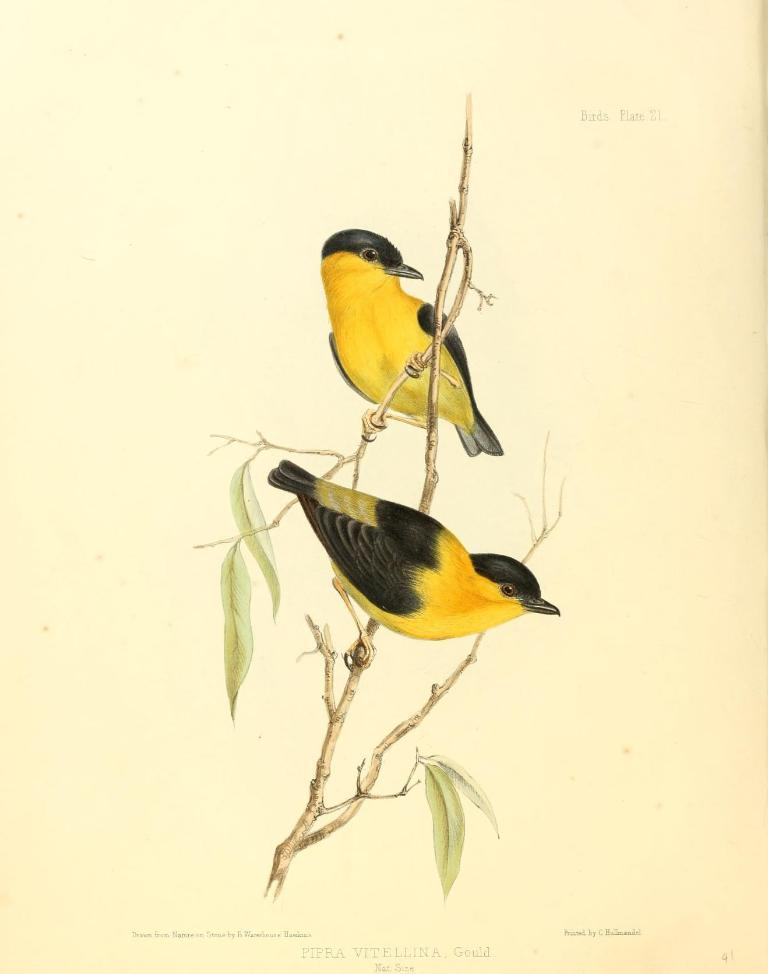What animals are present in the image? There are two birds in the image. Where are the birds located in the image? The birds are sitting on the stem of a plant. What shape is the body of the bird on the left side of the image? The image does not provide enough detail to determine the shape of the bird's body. 